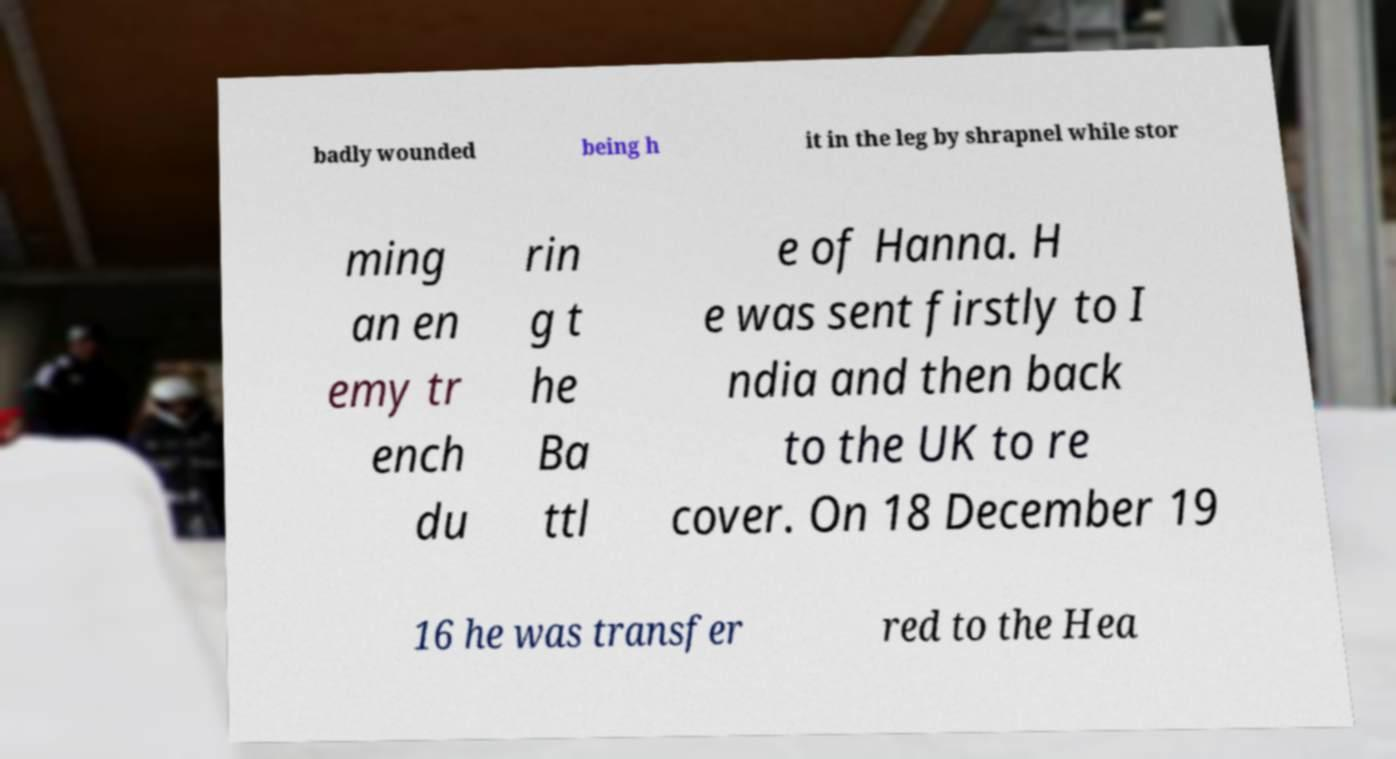There's text embedded in this image that I need extracted. Can you transcribe it verbatim? badly wounded being h it in the leg by shrapnel while stor ming an en emy tr ench du rin g t he Ba ttl e of Hanna. H e was sent firstly to I ndia and then back to the UK to re cover. On 18 December 19 16 he was transfer red to the Hea 